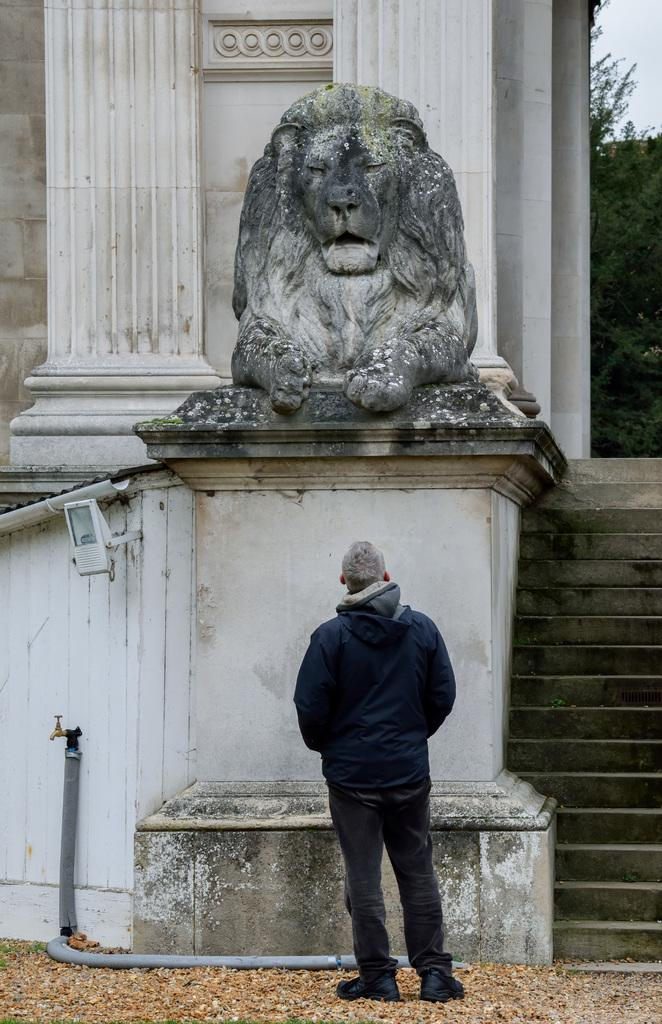What is the main subject in the image? There is a person standing in the image. What other objects or features can be seen in the image? There is a sculpture of a lion, a pipe, a tap, trees, and the sky visible in the top right corner of the image. What type of wall can be seen in the image? There is no wall present in the image. 